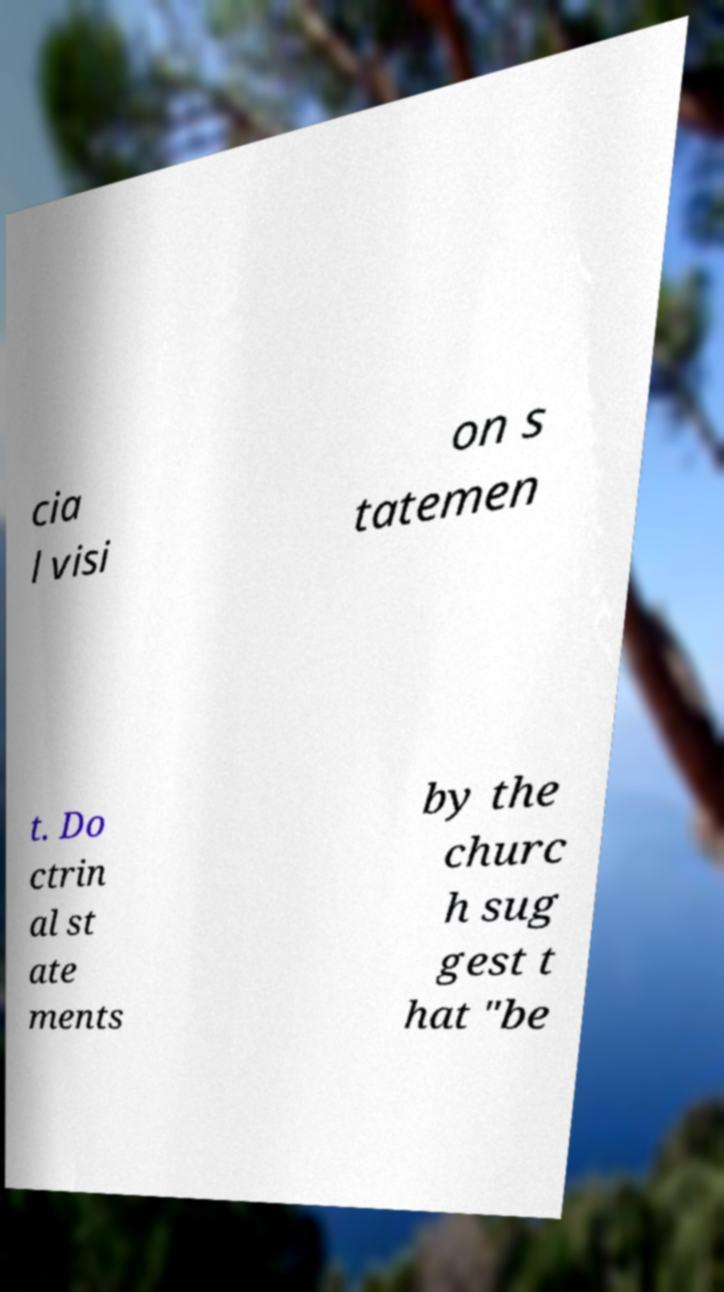Could you extract and type out the text from this image? cia l visi on s tatemen t. Do ctrin al st ate ments by the churc h sug gest t hat "be 